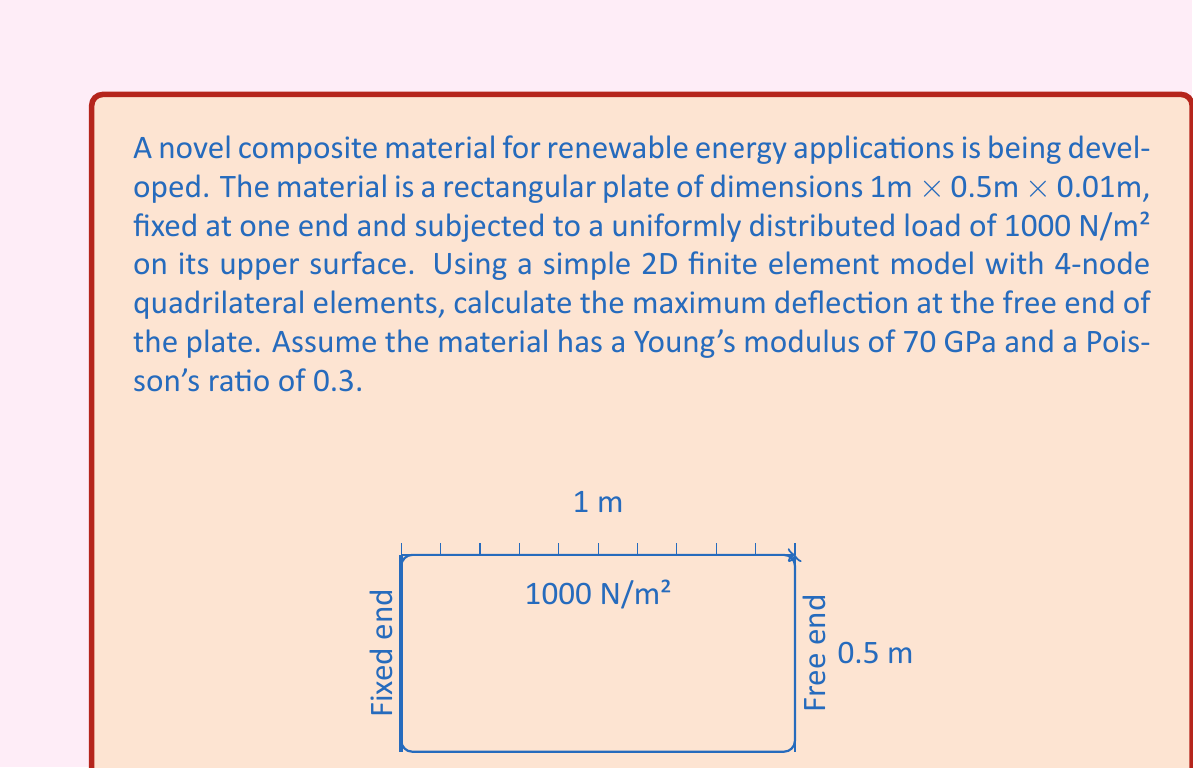Give your solution to this math problem. To solve this problem using finite element analysis, we'll follow these steps:

1) Discretize the domain:
   Let's use a 10x5 mesh of 4-node quadrilateral elements, resulting in 50 elements.

2) Element stiffness matrix:
   For a 4-node quadrilateral element, the stiffness matrix is given by:

   $$K_e = \int_A B^T D B \, dA$$

   where $B$ is the strain-displacement matrix and $D$ is the elasticity matrix.

3) Global stiffness matrix:
   Assemble the element stiffness matrices into the global stiffness matrix $K$.

4) Load vector:
   The distributed load of 1000 N/m² is converted to nodal forces.

5) Boundary conditions:
   Apply fixed boundary conditions at the left edge of the plate.

6) Solve the system:
   $$KU = F$$
   where $U$ is the displacement vector and $F$ is the force vector.

7) Post-processing:
   Extract the vertical displacement at the free end.

For a plate with these dimensions and material properties, we can use the following approximation for maximum deflection:

$$\delta_{max} = \frac{qL^4}{8EI}$$

where:
$q$ = distributed load = 1000 N/m²
$L$ = length of plate = 1 m
$E$ = Young's modulus = 70 GPa = 70 × 10⁹ Pa
$I$ = moment of inertia = $\frac{bh^3}{12}$ = $\frac{0.5 \times 0.01^3}{12}$ = 4.17 × 10⁻⁸ m⁴

Substituting these values:

$$\delta_{max} = \frac{1000 \times 1^4}{8 \times 70 \times 10^9 \times 4.17 \times 10^{-8}} = 0.0034 \text{ m}$$

This analytical solution provides a good approximation to verify the finite element results. The actual FEA result may differ slightly due to the simplifications in the model and the discretization used.
Answer: 3.4 mm 